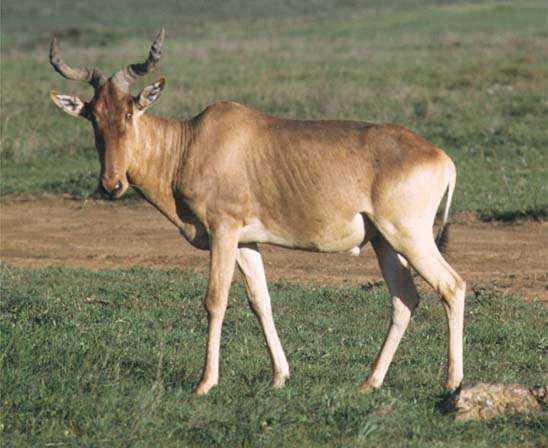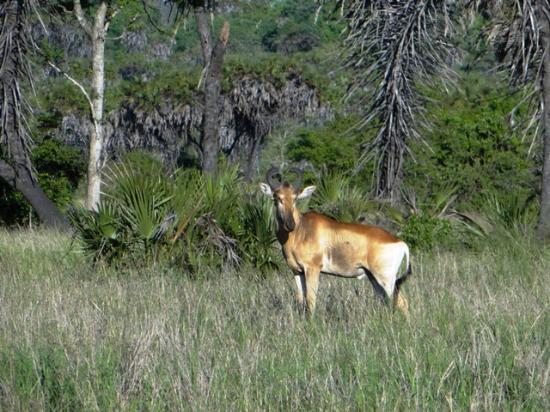The first image is the image on the left, the second image is the image on the right. For the images shown, is this caption "There is a total of two elk." true? Answer yes or no. Yes. The first image is the image on the left, the second image is the image on the right. For the images displayed, is the sentence "There are exactly two animals standing." factually correct? Answer yes or no. Yes. 